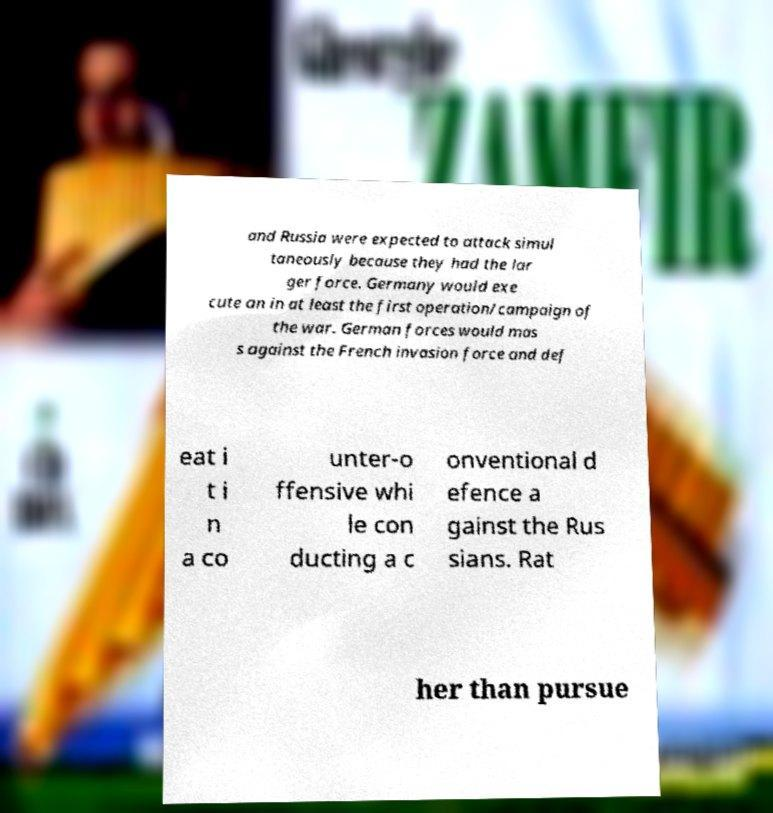For documentation purposes, I need the text within this image transcribed. Could you provide that? and Russia were expected to attack simul taneously because they had the lar ger force. Germany would exe cute an in at least the first operation/campaign of the war. German forces would mas s against the French invasion force and def eat i t i n a co unter-o ffensive whi le con ducting a c onventional d efence a gainst the Rus sians. Rat her than pursue 